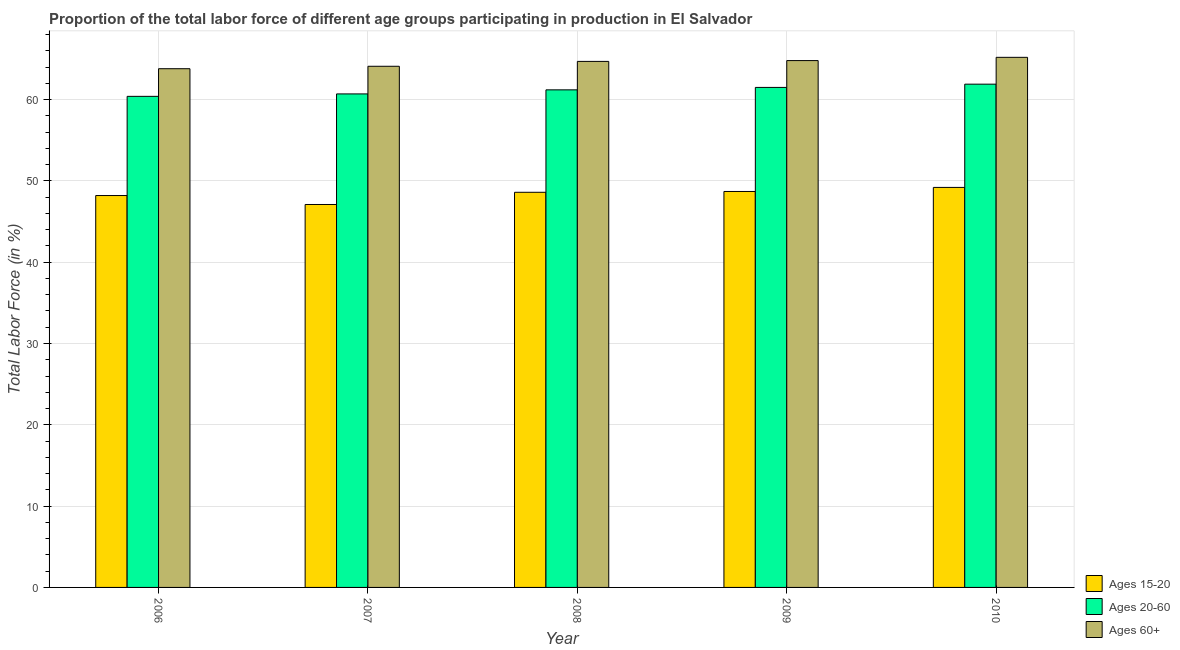Are the number of bars per tick equal to the number of legend labels?
Ensure brevity in your answer.  Yes. Are the number of bars on each tick of the X-axis equal?
Provide a succinct answer. Yes. How many bars are there on the 1st tick from the left?
Give a very brief answer. 3. What is the label of the 5th group of bars from the left?
Keep it short and to the point. 2010. What is the percentage of labor force above age 60 in 2007?
Keep it short and to the point. 64.1. Across all years, what is the maximum percentage of labor force within the age group 15-20?
Offer a very short reply. 49.2. Across all years, what is the minimum percentage of labor force within the age group 20-60?
Provide a succinct answer. 60.4. In which year was the percentage of labor force within the age group 15-20 maximum?
Ensure brevity in your answer.  2010. In which year was the percentage of labor force above age 60 minimum?
Your response must be concise. 2006. What is the total percentage of labor force within the age group 15-20 in the graph?
Provide a succinct answer. 241.8. What is the difference between the percentage of labor force within the age group 15-20 in 2006 and that in 2009?
Provide a succinct answer. -0.5. What is the difference between the percentage of labor force above age 60 in 2010 and the percentage of labor force within the age group 20-60 in 2009?
Provide a succinct answer. 0.4. What is the average percentage of labor force above age 60 per year?
Your answer should be compact. 64.52. In how many years, is the percentage of labor force within the age group 20-60 greater than 28 %?
Your response must be concise. 5. What is the ratio of the percentage of labor force above age 60 in 2008 to that in 2010?
Offer a terse response. 0.99. What is the difference between the highest and the second highest percentage of labor force within the age group 20-60?
Offer a terse response. 0.4. What is the difference between the highest and the lowest percentage of labor force within the age group 15-20?
Make the answer very short. 2.1. Is the sum of the percentage of labor force within the age group 15-20 in 2006 and 2009 greater than the maximum percentage of labor force within the age group 20-60 across all years?
Your response must be concise. Yes. What does the 1st bar from the left in 2009 represents?
Make the answer very short. Ages 15-20. What does the 3rd bar from the right in 2008 represents?
Give a very brief answer. Ages 15-20. How many bars are there?
Make the answer very short. 15. How many years are there in the graph?
Make the answer very short. 5. What is the difference between two consecutive major ticks on the Y-axis?
Keep it short and to the point. 10. Are the values on the major ticks of Y-axis written in scientific E-notation?
Offer a very short reply. No. Does the graph contain grids?
Give a very brief answer. Yes. What is the title of the graph?
Make the answer very short. Proportion of the total labor force of different age groups participating in production in El Salvador. What is the label or title of the X-axis?
Make the answer very short. Year. What is the label or title of the Y-axis?
Ensure brevity in your answer.  Total Labor Force (in %). What is the Total Labor Force (in %) in Ages 15-20 in 2006?
Ensure brevity in your answer.  48.2. What is the Total Labor Force (in %) in Ages 20-60 in 2006?
Provide a succinct answer. 60.4. What is the Total Labor Force (in %) of Ages 60+ in 2006?
Your answer should be compact. 63.8. What is the Total Labor Force (in %) of Ages 15-20 in 2007?
Provide a succinct answer. 47.1. What is the Total Labor Force (in %) in Ages 20-60 in 2007?
Keep it short and to the point. 60.7. What is the Total Labor Force (in %) in Ages 60+ in 2007?
Give a very brief answer. 64.1. What is the Total Labor Force (in %) of Ages 15-20 in 2008?
Offer a very short reply. 48.6. What is the Total Labor Force (in %) of Ages 20-60 in 2008?
Ensure brevity in your answer.  61.2. What is the Total Labor Force (in %) of Ages 60+ in 2008?
Your answer should be compact. 64.7. What is the Total Labor Force (in %) in Ages 15-20 in 2009?
Offer a terse response. 48.7. What is the Total Labor Force (in %) of Ages 20-60 in 2009?
Provide a succinct answer. 61.5. What is the Total Labor Force (in %) in Ages 60+ in 2009?
Provide a succinct answer. 64.8. What is the Total Labor Force (in %) of Ages 15-20 in 2010?
Offer a very short reply. 49.2. What is the Total Labor Force (in %) of Ages 20-60 in 2010?
Your answer should be very brief. 61.9. What is the Total Labor Force (in %) of Ages 60+ in 2010?
Offer a terse response. 65.2. Across all years, what is the maximum Total Labor Force (in %) in Ages 15-20?
Give a very brief answer. 49.2. Across all years, what is the maximum Total Labor Force (in %) in Ages 20-60?
Give a very brief answer. 61.9. Across all years, what is the maximum Total Labor Force (in %) of Ages 60+?
Give a very brief answer. 65.2. Across all years, what is the minimum Total Labor Force (in %) of Ages 15-20?
Your answer should be very brief. 47.1. Across all years, what is the minimum Total Labor Force (in %) of Ages 20-60?
Provide a succinct answer. 60.4. Across all years, what is the minimum Total Labor Force (in %) in Ages 60+?
Make the answer very short. 63.8. What is the total Total Labor Force (in %) in Ages 15-20 in the graph?
Give a very brief answer. 241.8. What is the total Total Labor Force (in %) of Ages 20-60 in the graph?
Your response must be concise. 305.7. What is the total Total Labor Force (in %) in Ages 60+ in the graph?
Offer a very short reply. 322.6. What is the difference between the Total Labor Force (in %) of Ages 60+ in 2006 and that in 2008?
Give a very brief answer. -0.9. What is the difference between the Total Labor Force (in %) in Ages 60+ in 2006 and that in 2009?
Offer a very short reply. -1. What is the difference between the Total Labor Force (in %) of Ages 15-20 in 2006 and that in 2010?
Provide a succinct answer. -1. What is the difference between the Total Labor Force (in %) in Ages 20-60 in 2006 and that in 2010?
Offer a very short reply. -1.5. What is the difference between the Total Labor Force (in %) of Ages 60+ in 2006 and that in 2010?
Provide a short and direct response. -1.4. What is the difference between the Total Labor Force (in %) of Ages 15-20 in 2007 and that in 2008?
Your response must be concise. -1.5. What is the difference between the Total Labor Force (in %) in Ages 20-60 in 2007 and that in 2008?
Offer a terse response. -0.5. What is the difference between the Total Labor Force (in %) in Ages 60+ in 2007 and that in 2008?
Offer a terse response. -0.6. What is the difference between the Total Labor Force (in %) of Ages 15-20 in 2007 and that in 2009?
Your answer should be very brief. -1.6. What is the difference between the Total Labor Force (in %) in Ages 20-60 in 2007 and that in 2009?
Make the answer very short. -0.8. What is the difference between the Total Labor Force (in %) of Ages 60+ in 2007 and that in 2009?
Your answer should be compact. -0.7. What is the difference between the Total Labor Force (in %) of Ages 15-20 in 2007 and that in 2010?
Keep it short and to the point. -2.1. What is the difference between the Total Labor Force (in %) of Ages 15-20 in 2008 and that in 2009?
Your answer should be very brief. -0.1. What is the difference between the Total Labor Force (in %) of Ages 60+ in 2008 and that in 2009?
Offer a very short reply. -0.1. What is the difference between the Total Labor Force (in %) in Ages 20-60 in 2008 and that in 2010?
Provide a succinct answer. -0.7. What is the difference between the Total Labor Force (in %) of Ages 15-20 in 2009 and that in 2010?
Offer a very short reply. -0.5. What is the difference between the Total Labor Force (in %) in Ages 60+ in 2009 and that in 2010?
Provide a short and direct response. -0.4. What is the difference between the Total Labor Force (in %) in Ages 15-20 in 2006 and the Total Labor Force (in %) in Ages 20-60 in 2007?
Ensure brevity in your answer.  -12.5. What is the difference between the Total Labor Force (in %) in Ages 15-20 in 2006 and the Total Labor Force (in %) in Ages 60+ in 2007?
Offer a very short reply. -15.9. What is the difference between the Total Labor Force (in %) in Ages 15-20 in 2006 and the Total Labor Force (in %) in Ages 60+ in 2008?
Your response must be concise. -16.5. What is the difference between the Total Labor Force (in %) in Ages 20-60 in 2006 and the Total Labor Force (in %) in Ages 60+ in 2008?
Your response must be concise. -4.3. What is the difference between the Total Labor Force (in %) of Ages 15-20 in 2006 and the Total Labor Force (in %) of Ages 20-60 in 2009?
Offer a terse response. -13.3. What is the difference between the Total Labor Force (in %) of Ages 15-20 in 2006 and the Total Labor Force (in %) of Ages 60+ in 2009?
Provide a succinct answer. -16.6. What is the difference between the Total Labor Force (in %) in Ages 20-60 in 2006 and the Total Labor Force (in %) in Ages 60+ in 2009?
Offer a very short reply. -4.4. What is the difference between the Total Labor Force (in %) of Ages 15-20 in 2006 and the Total Labor Force (in %) of Ages 20-60 in 2010?
Offer a very short reply. -13.7. What is the difference between the Total Labor Force (in %) in Ages 15-20 in 2006 and the Total Labor Force (in %) in Ages 60+ in 2010?
Ensure brevity in your answer.  -17. What is the difference between the Total Labor Force (in %) of Ages 15-20 in 2007 and the Total Labor Force (in %) of Ages 20-60 in 2008?
Keep it short and to the point. -14.1. What is the difference between the Total Labor Force (in %) of Ages 15-20 in 2007 and the Total Labor Force (in %) of Ages 60+ in 2008?
Keep it short and to the point. -17.6. What is the difference between the Total Labor Force (in %) of Ages 15-20 in 2007 and the Total Labor Force (in %) of Ages 20-60 in 2009?
Your answer should be compact. -14.4. What is the difference between the Total Labor Force (in %) in Ages 15-20 in 2007 and the Total Labor Force (in %) in Ages 60+ in 2009?
Ensure brevity in your answer.  -17.7. What is the difference between the Total Labor Force (in %) of Ages 20-60 in 2007 and the Total Labor Force (in %) of Ages 60+ in 2009?
Offer a terse response. -4.1. What is the difference between the Total Labor Force (in %) of Ages 15-20 in 2007 and the Total Labor Force (in %) of Ages 20-60 in 2010?
Your response must be concise. -14.8. What is the difference between the Total Labor Force (in %) of Ages 15-20 in 2007 and the Total Labor Force (in %) of Ages 60+ in 2010?
Ensure brevity in your answer.  -18.1. What is the difference between the Total Labor Force (in %) of Ages 20-60 in 2007 and the Total Labor Force (in %) of Ages 60+ in 2010?
Your answer should be compact. -4.5. What is the difference between the Total Labor Force (in %) of Ages 15-20 in 2008 and the Total Labor Force (in %) of Ages 60+ in 2009?
Make the answer very short. -16.2. What is the difference between the Total Labor Force (in %) in Ages 20-60 in 2008 and the Total Labor Force (in %) in Ages 60+ in 2009?
Offer a terse response. -3.6. What is the difference between the Total Labor Force (in %) in Ages 15-20 in 2008 and the Total Labor Force (in %) in Ages 20-60 in 2010?
Offer a terse response. -13.3. What is the difference between the Total Labor Force (in %) of Ages 15-20 in 2008 and the Total Labor Force (in %) of Ages 60+ in 2010?
Your answer should be compact. -16.6. What is the difference between the Total Labor Force (in %) of Ages 20-60 in 2008 and the Total Labor Force (in %) of Ages 60+ in 2010?
Offer a terse response. -4. What is the difference between the Total Labor Force (in %) in Ages 15-20 in 2009 and the Total Labor Force (in %) in Ages 20-60 in 2010?
Your answer should be compact. -13.2. What is the difference between the Total Labor Force (in %) of Ages 15-20 in 2009 and the Total Labor Force (in %) of Ages 60+ in 2010?
Provide a short and direct response. -16.5. What is the average Total Labor Force (in %) in Ages 15-20 per year?
Provide a short and direct response. 48.36. What is the average Total Labor Force (in %) of Ages 20-60 per year?
Provide a short and direct response. 61.14. What is the average Total Labor Force (in %) in Ages 60+ per year?
Your answer should be compact. 64.52. In the year 2006, what is the difference between the Total Labor Force (in %) of Ages 15-20 and Total Labor Force (in %) of Ages 60+?
Your answer should be very brief. -15.6. In the year 2007, what is the difference between the Total Labor Force (in %) in Ages 15-20 and Total Labor Force (in %) in Ages 60+?
Provide a short and direct response. -17. In the year 2008, what is the difference between the Total Labor Force (in %) in Ages 15-20 and Total Labor Force (in %) in Ages 20-60?
Provide a short and direct response. -12.6. In the year 2008, what is the difference between the Total Labor Force (in %) in Ages 15-20 and Total Labor Force (in %) in Ages 60+?
Ensure brevity in your answer.  -16.1. In the year 2008, what is the difference between the Total Labor Force (in %) in Ages 20-60 and Total Labor Force (in %) in Ages 60+?
Your answer should be compact. -3.5. In the year 2009, what is the difference between the Total Labor Force (in %) in Ages 15-20 and Total Labor Force (in %) in Ages 20-60?
Make the answer very short. -12.8. In the year 2009, what is the difference between the Total Labor Force (in %) in Ages 15-20 and Total Labor Force (in %) in Ages 60+?
Provide a succinct answer. -16.1. In the year 2009, what is the difference between the Total Labor Force (in %) of Ages 20-60 and Total Labor Force (in %) of Ages 60+?
Offer a terse response. -3.3. What is the ratio of the Total Labor Force (in %) of Ages 15-20 in 2006 to that in 2007?
Give a very brief answer. 1.02. What is the ratio of the Total Labor Force (in %) in Ages 20-60 in 2006 to that in 2007?
Your answer should be very brief. 1. What is the ratio of the Total Labor Force (in %) of Ages 60+ in 2006 to that in 2007?
Provide a succinct answer. 1. What is the ratio of the Total Labor Force (in %) in Ages 15-20 in 2006 to that in 2008?
Keep it short and to the point. 0.99. What is the ratio of the Total Labor Force (in %) of Ages 20-60 in 2006 to that in 2008?
Your response must be concise. 0.99. What is the ratio of the Total Labor Force (in %) of Ages 60+ in 2006 to that in 2008?
Offer a very short reply. 0.99. What is the ratio of the Total Labor Force (in %) of Ages 20-60 in 2006 to that in 2009?
Your response must be concise. 0.98. What is the ratio of the Total Labor Force (in %) in Ages 60+ in 2006 to that in 2009?
Offer a very short reply. 0.98. What is the ratio of the Total Labor Force (in %) of Ages 15-20 in 2006 to that in 2010?
Keep it short and to the point. 0.98. What is the ratio of the Total Labor Force (in %) in Ages 20-60 in 2006 to that in 2010?
Provide a short and direct response. 0.98. What is the ratio of the Total Labor Force (in %) in Ages 60+ in 2006 to that in 2010?
Offer a very short reply. 0.98. What is the ratio of the Total Labor Force (in %) in Ages 15-20 in 2007 to that in 2008?
Your answer should be compact. 0.97. What is the ratio of the Total Labor Force (in %) of Ages 15-20 in 2007 to that in 2009?
Offer a very short reply. 0.97. What is the ratio of the Total Labor Force (in %) in Ages 15-20 in 2007 to that in 2010?
Offer a terse response. 0.96. What is the ratio of the Total Labor Force (in %) in Ages 20-60 in 2007 to that in 2010?
Offer a very short reply. 0.98. What is the ratio of the Total Labor Force (in %) of Ages 60+ in 2007 to that in 2010?
Your answer should be very brief. 0.98. What is the ratio of the Total Labor Force (in %) of Ages 20-60 in 2008 to that in 2010?
Give a very brief answer. 0.99. What is the ratio of the Total Labor Force (in %) in Ages 60+ in 2008 to that in 2010?
Provide a succinct answer. 0.99. What is the ratio of the Total Labor Force (in %) in Ages 15-20 in 2009 to that in 2010?
Give a very brief answer. 0.99. What is the ratio of the Total Labor Force (in %) of Ages 20-60 in 2009 to that in 2010?
Provide a succinct answer. 0.99. What is the ratio of the Total Labor Force (in %) in Ages 60+ in 2009 to that in 2010?
Ensure brevity in your answer.  0.99. What is the difference between the highest and the second highest Total Labor Force (in %) in Ages 60+?
Your answer should be very brief. 0.4. What is the difference between the highest and the lowest Total Labor Force (in %) in Ages 60+?
Your answer should be very brief. 1.4. 